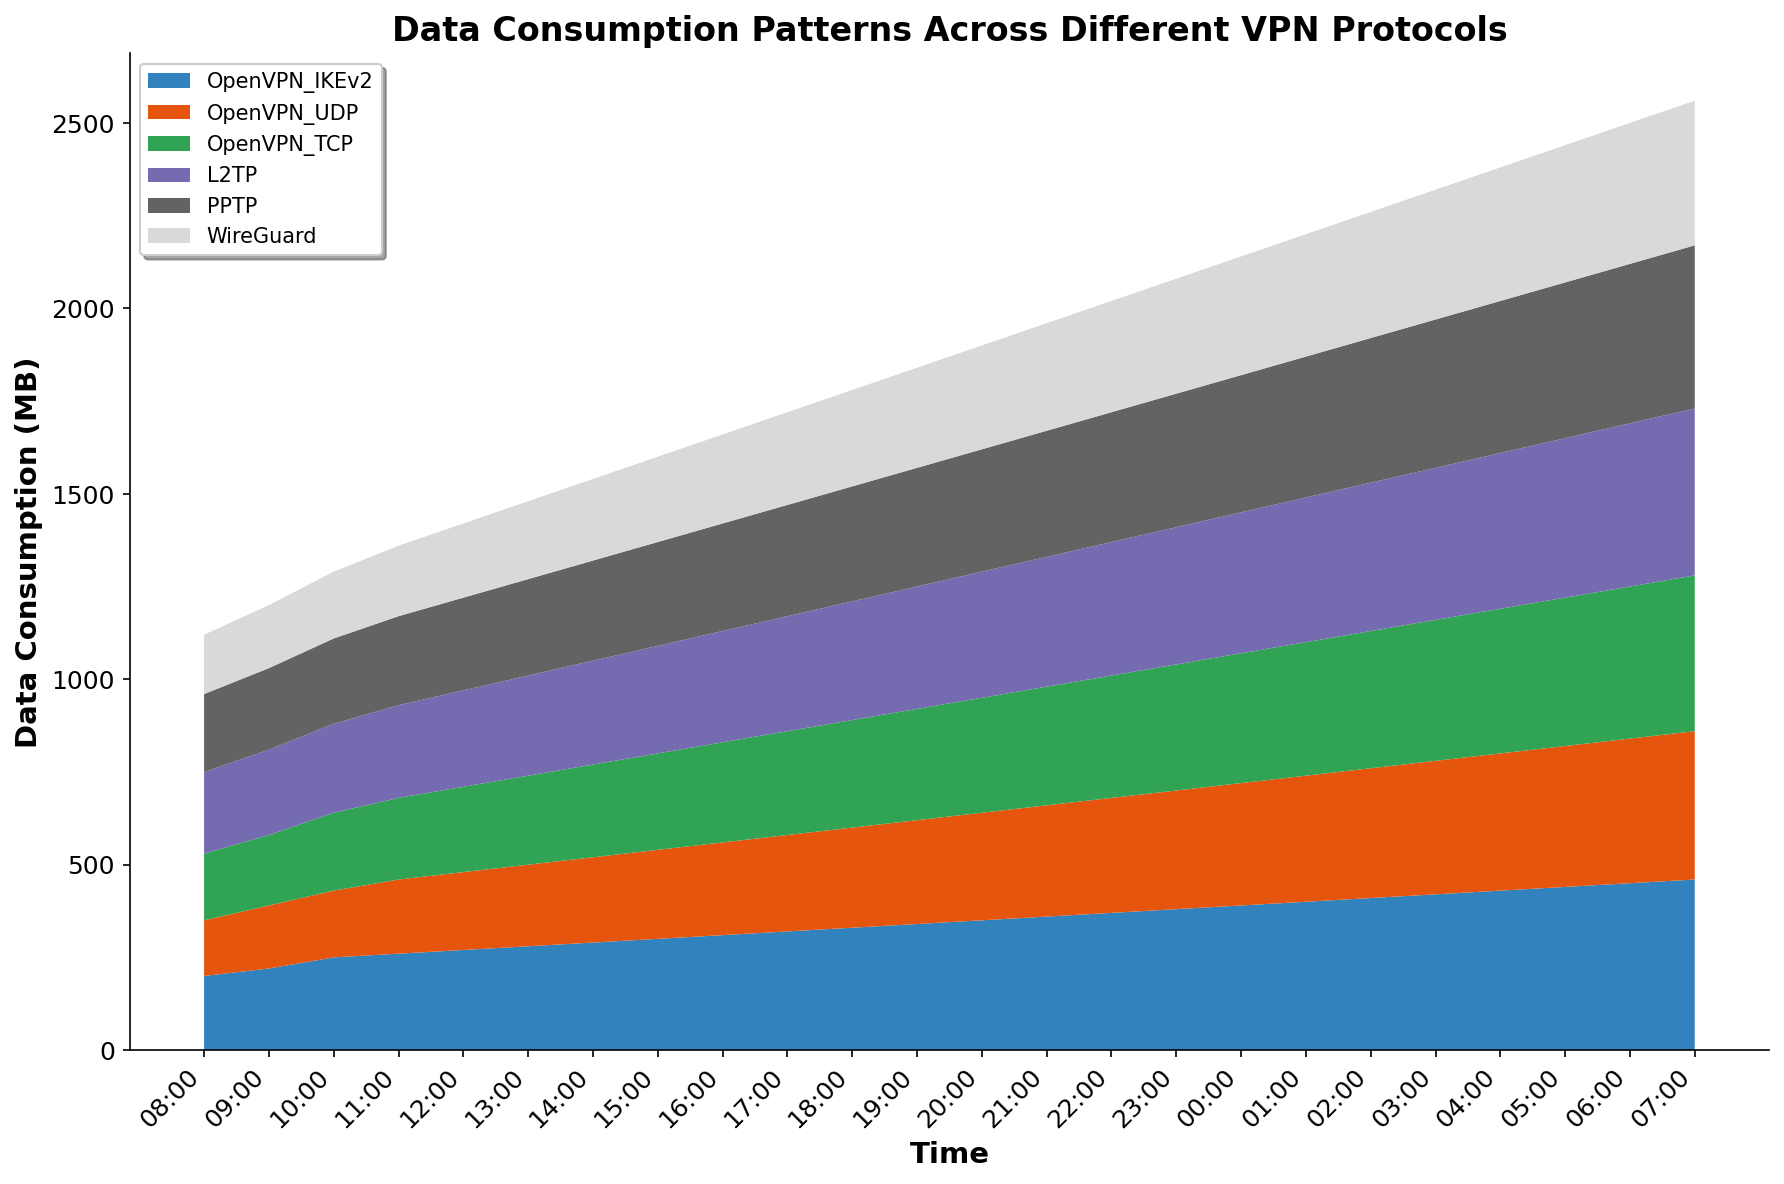What time of the day does the data consumption for OpenVPN_IKEv2 start to consistently exceed 300 MB? To determine this, locate the point in the area chart where the OpenVPN_IKEv2 area (often in a specific color) crosses the 300 MB threshold.
Answer: 15:00 Which VPN protocol has the least variability in data consumption throughout the day? Analyze the plot to observe which protocol's area remains the most consistent and least fluctuating throughout all the time intervals.
Answer: WireGuard At what time is the cumulative data consumption for OpenVPN_TCP and L2TP the highest? Sum the data consumption values of OpenVPN_TCP and L2TP across different times and identify which time has the maximum sum.
Answer: 07:00 How does the data consumption of PPTP at 12:00 compare to that at 00:00? Observe the heights of the areas for PPTP at 12:00 and 00:00 and compare the values provided on the vertical axis.
Answer: 12:00 is lower than 00:00 Which protocol shows the steepest increase in data consumption during the period from 08:00 to 23:00? Identify the protocol with the greatest change in height (data consumption) from the start to the end of the specified time period.
Answer: OpenVPN_IKEv2 What is the total data consumption for all protocols combined at 18:00? Sum the data consumption values of all the protocols at the time 18:00 from the provided dataset. The sum is 330 (OpenVPN_IKEv2) + 270 (OpenVPN_UDP) + 290 (OpenVPN_TCP) + 320 (L2TP) + 310 (PPTP) + 260 (WireGuard).
Answer: 1780 MB At what time does WireGuard data consumption first exceed 250 MB? Locate the first time in the area chart where WireGuard's area rises above 250 MB.
Answer: 21:00 Does PPTP's data consumption ever decrease or does it continuously increase? Analyze the progression of PPTP's area data from 08:00 to 07:00 to see if there are any downward trends or if the values continuously rise.
Answer: Continuously increases Which two protocols have the closest data consumption values at 04:00? Compare the data consumption values of all protocols at 04:00 and identify the two with the smallest difference between them.
Answer: OpenVPN_UDP and WireGuard How much more data does OpenVPN_TCP consume at 21:00 compared to 15:00? Extract the data consumption values for OpenVPN_TCP at 21:00 and 15:00, then calculate the difference, which is 320 (at 21:00) - 260 (at 15:00).
Answer: 60 MB 